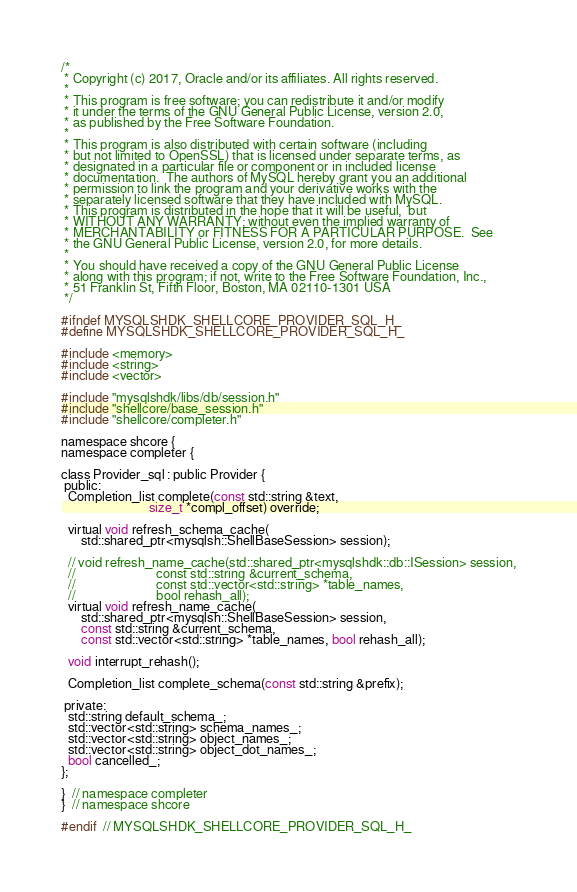Convert code to text. <code><loc_0><loc_0><loc_500><loc_500><_C_>/*
 * Copyright (c) 2017, Oracle and/or its affiliates. All rights reserved.
 *
 * This program is free software; you can redistribute it and/or modify
 * it under the terms of the GNU General Public License, version 2.0,
 * as published by the Free Software Foundation.
 *
 * This program is also distributed with certain software (including
 * but not limited to OpenSSL) that is licensed under separate terms, as
 * designated in a particular file or component or in included license
 * documentation.  The authors of MySQL hereby grant you an additional
 * permission to link the program and your derivative works with the
 * separately licensed software that they have included with MySQL.
 * This program is distributed in the hope that it will be useful,  but
 * WITHOUT ANY WARRANTY; without even the implied warranty of
 * MERCHANTABILITY or FITNESS FOR A PARTICULAR PURPOSE.  See
 * the GNU General Public License, version 2.0, for more details.
 *
 * You should have received a copy of the GNU General Public License
 * along with this program; if not, write to the Free Software Foundation, Inc.,
 * 51 Franklin St, Fifth Floor, Boston, MA 02110-1301 USA
 */

#ifndef MYSQLSHDK_SHELLCORE_PROVIDER_SQL_H_
#define MYSQLSHDK_SHELLCORE_PROVIDER_SQL_H_

#include <memory>
#include <string>
#include <vector>

#include "mysqlshdk/libs/db/session.h"
#include "shellcore/base_session.h"
#include "shellcore/completer.h"

namespace shcore {
namespace completer {

class Provider_sql : public Provider {
 public:
  Completion_list complete(const std::string &text,
                           size_t *compl_offset) override;

  virtual void refresh_schema_cache(
      std::shared_ptr<mysqlsh::ShellBaseSession> session);

  // void refresh_name_cache(std::shared_ptr<mysqlshdk::db::ISession> session,
  //                         const std::string &current_schema,
  //                         const std::vector<std::string> *table_names,
  //                         bool rehash_all);
  virtual void refresh_name_cache(
      std::shared_ptr<mysqlsh::ShellBaseSession> session,
      const std::string &current_schema,
      const std::vector<std::string> *table_names, bool rehash_all);

  void interrupt_rehash();

  Completion_list complete_schema(const std::string &prefix);

 private:
  std::string default_schema_;
  std::vector<std::string> schema_names_;
  std::vector<std::string> object_names_;
  std::vector<std::string> object_dot_names_;
  bool cancelled_;
};

}  // namespace completer
}  // namespace shcore

#endif  // MYSQLSHDK_SHELLCORE_PROVIDER_SQL_H_
</code> 